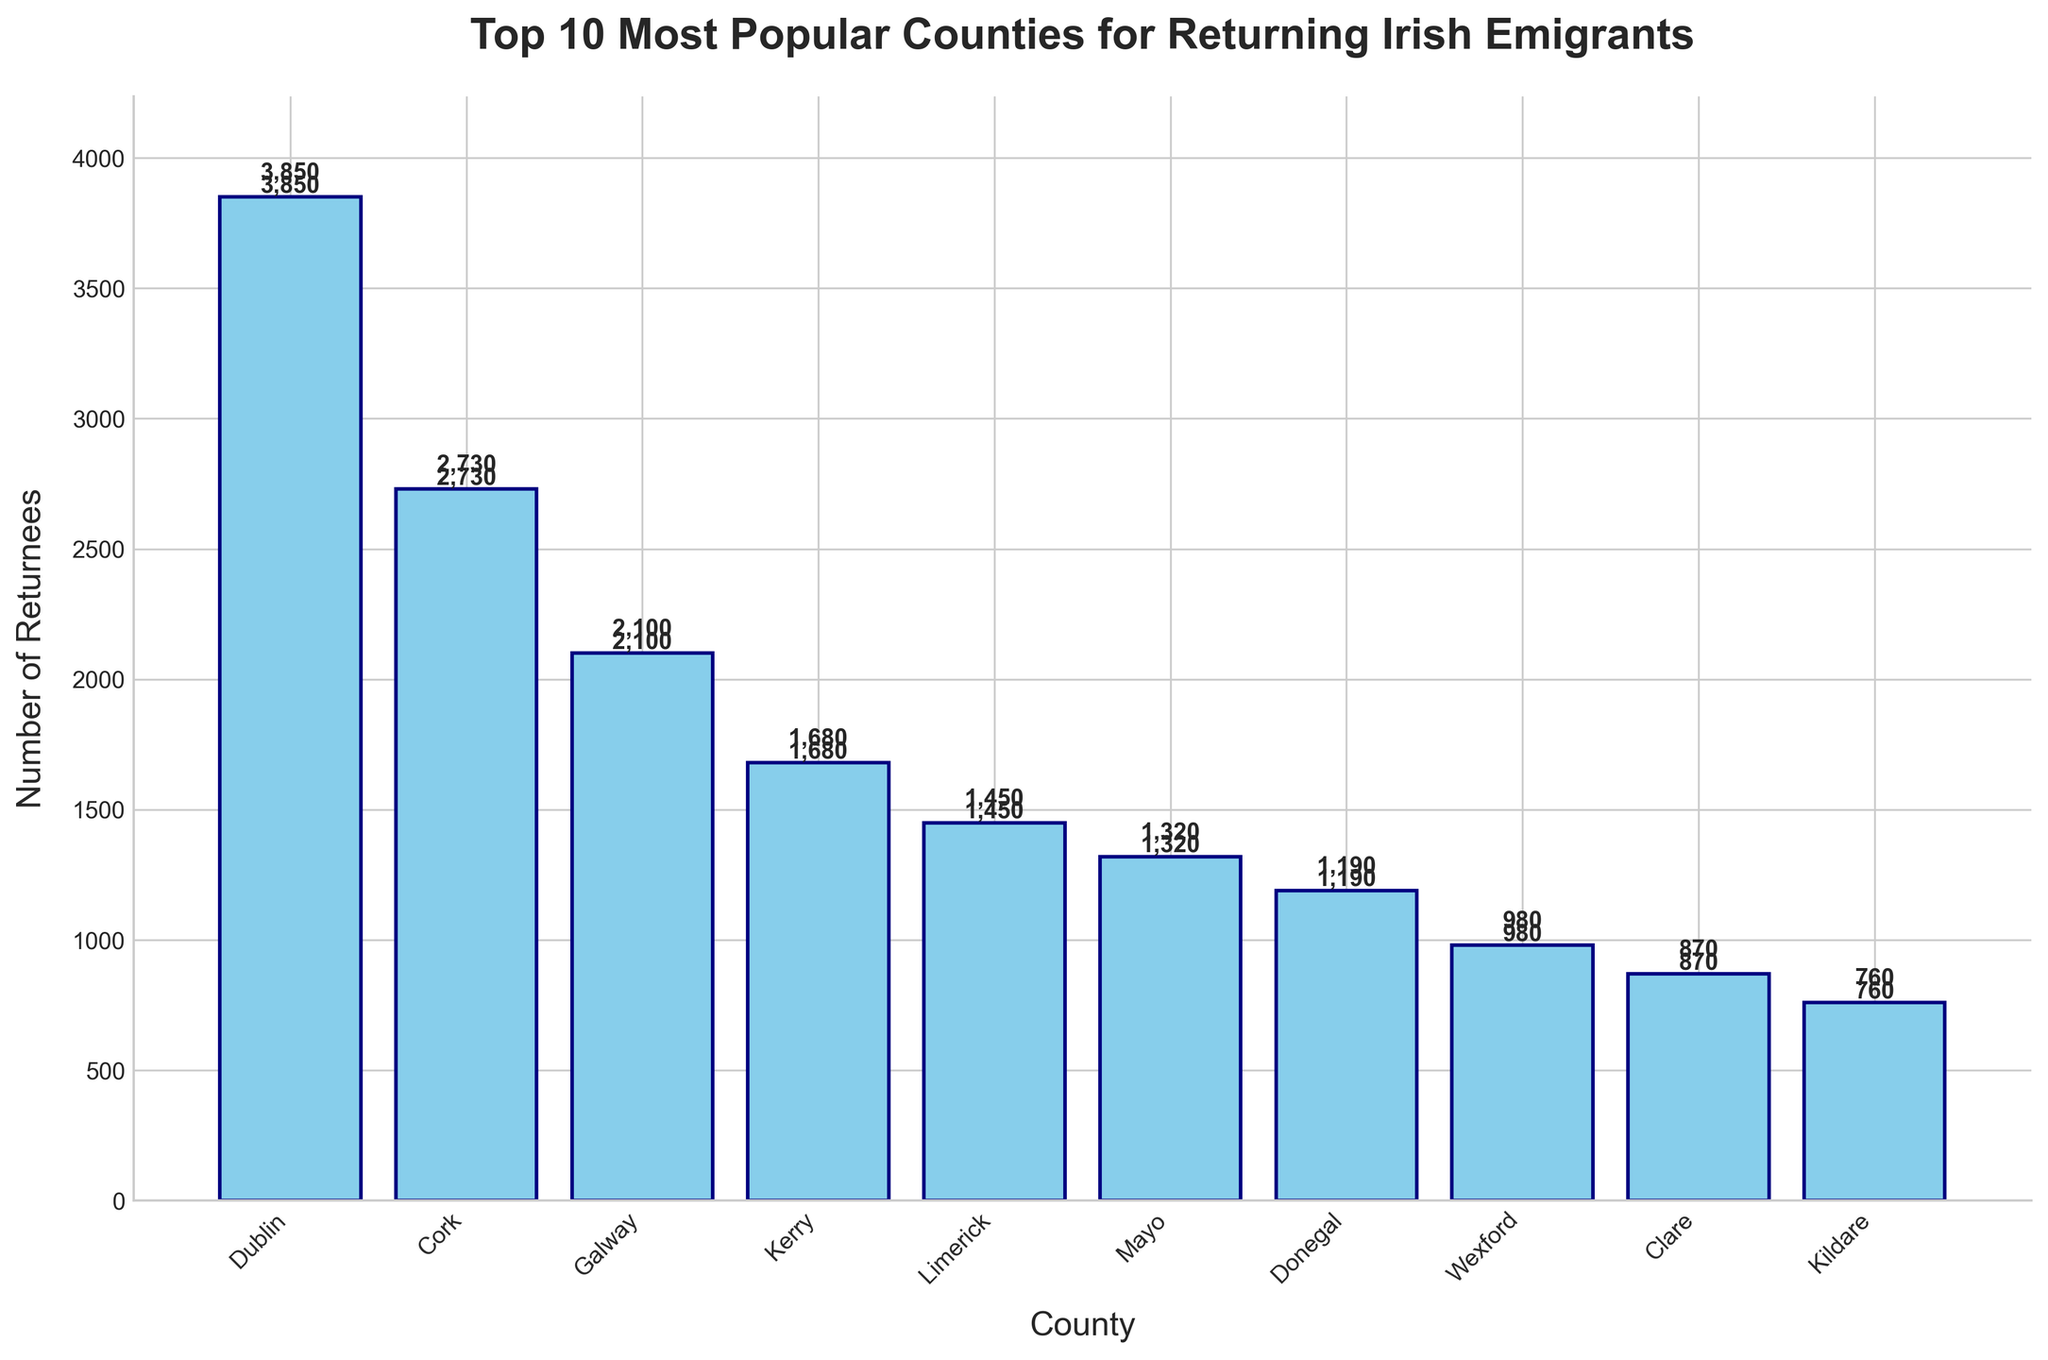Which county has the highest number of returnees? The county with the highest bar represents the highest number of returnees. In this case, it is Dublin with 3850 returnees.
Answer: Dublin Which two counties combined have the highest total number of returnees? We add the numbers of returnees from the top two counties, which are Dublin (3850) and Cork (2730). Their combined total is 3850 + 2730 = 6580.
Answer: Dublin and Cork Which county has the fewest returnees? The county with the shortest bar represents the fewest number of returnees. In this case, it is Kildare with 760 returnees.
Answer: Kildare How many more returnees does Galway have compared to Donegal? Subtract the number of returnees in Donegal (1190) from those in Galway (2100). 2100 - 1190 = 910.
Answer: 910 What is the average number of returnees across all counties? Sum up the number of returnees for all counties (3850 + 2730 + 2100 + 1680 + 1450 + 1320 + 1190 + 980 + 870 + 760 = 16930) and divide by the number of counties (10). The average is 16930 / 10 = 1693.
Answer: 1693 Which county ranks 5th in the number of returnees? The fifth highest bar represents the 5th ranked county in terms of returnees, which is Limerick with 1450 returnees.
Answer: Limerick What is the combined total of returnees for the bottom three counties? Sum up the returnees for the bottom three counties (Wexford, Clare, and Kildare). 980 + 870 + 760 = 2610.
Answer: 2610 How many counties have more than 2000 returnees? Count the number of bars that extend above the 2000 mark. Only Dublin (3850), Cork (2730), and Galway (2100) meet this condition.
Answer: 3 What is the total number of returnees for counties that have more than 1000 returnees? Sum up the number of returnees for counties that have more than 1000 returnees (Dublin, Cork, Galway, Kerry, Limerick, Mayo, Donegal). 3850 + 2730 + 2100 + 1680 + 1450 + 1320 + 1190 = 14320.
Answer: 14320 Which county has a higher number of returnees, Mayo or Clare? Compare the height of the bars for Mayo and Clare. Mayo has 1320 returnees while Clare has 870. Mayo has more.
Answer: Mayo 